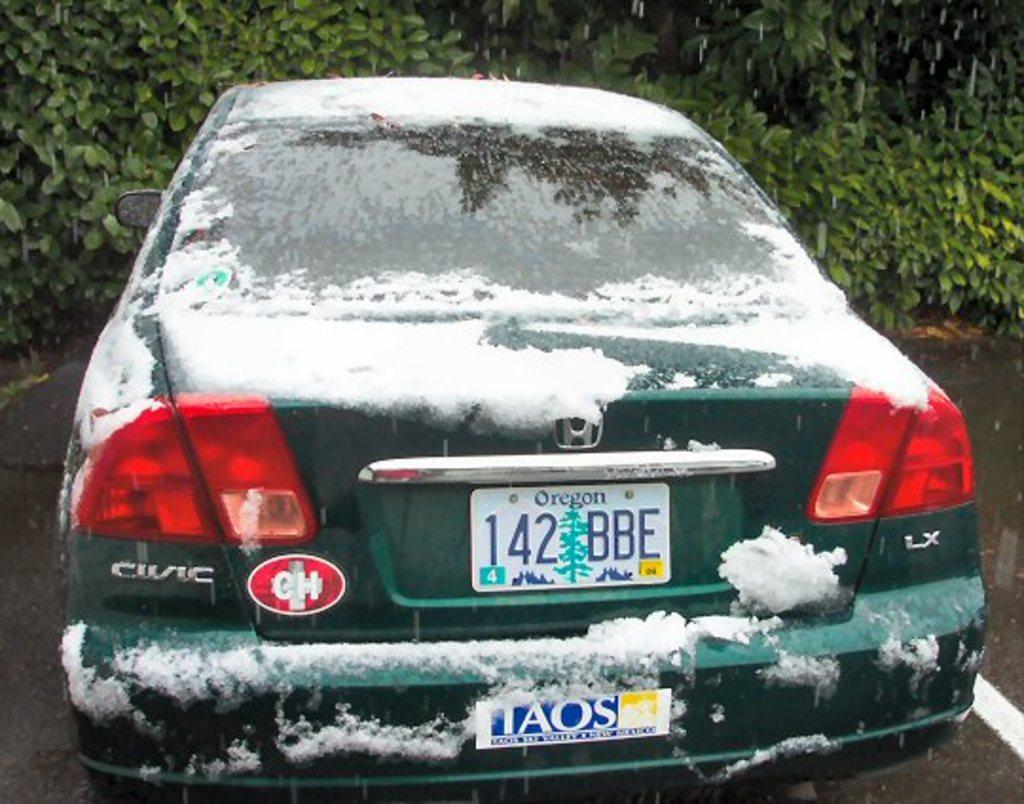<image>
Present a compact description of the photo's key features. A green Honda Civic with an Oregon license plate has snow on it and is parked in front bushes. 